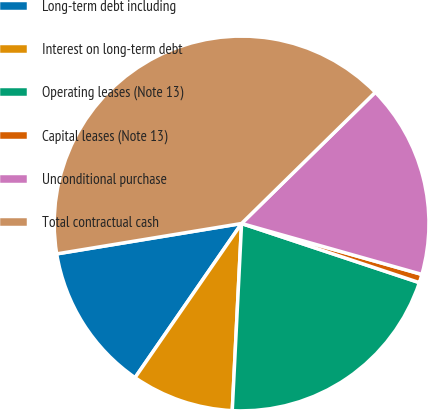<chart> <loc_0><loc_0><loc_500><loc_500><pie_chart><fcel>Long-term debt including<fcel>Interest on long-term debt<fcel>Operating leases (Note 13)<fcel>Capital leases (Note 13)<fcel>Unconditional purchase<fcel>Total contractual cash<nl><fcel>12.78%<fcel>8.83%<fcel>20.68%<fcel>0.73%<fcel>16.73%<fcel>40.24%<nl></chart> 